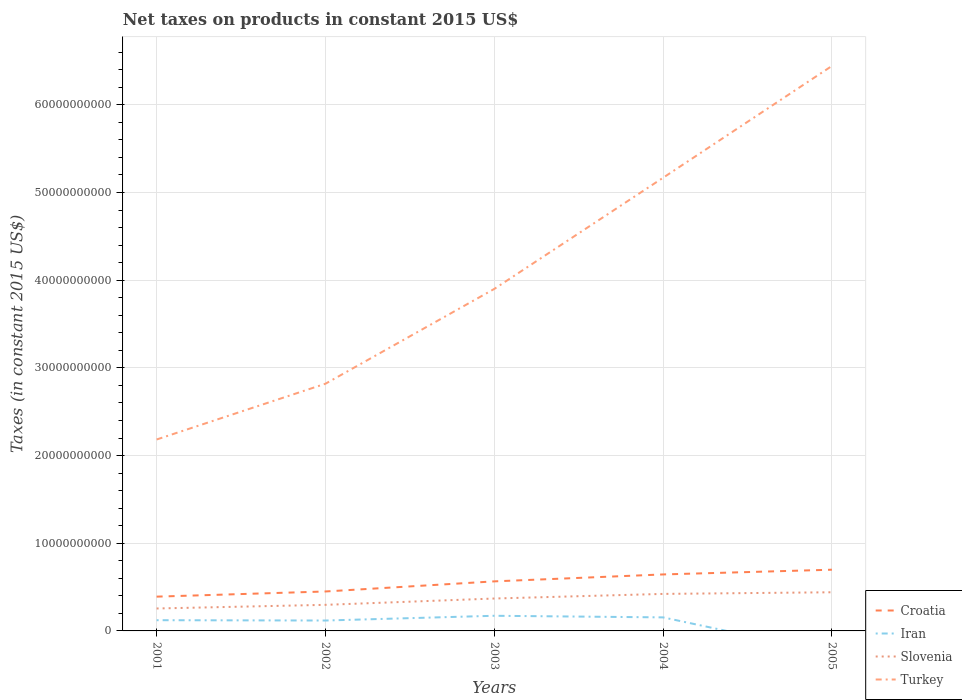Is the number of lines equal to the number of legend labels?
Ensure brevity in your answer.  No. Across all years, what is the maximum net taxes on products in Slovenia?
Give a very brief answer. 2.56e+09. What is the total net taxes on products in Croatia in the graph?
Keep it short and to the point. -5.90e+08. What is the difference between the highest and the second highest net taxes on products in Croatia?
Ensure brevity in your answer.  3.07e+09. Is the net taxes on products in Slovenia strictly greater than the net taxes on products in Turkey over the years?
Ensure brevity in your answer.  Yes. What is the difference between two consecutive major ticks on the Y-axis?
Ensure brevity in your answer.  1.00e+1. Are the values on the major ticks of Y-axis written in scientific E-notation?
Give a very brief answer. No. Does the graph contain any zero values?
Your response must be concise. Yes. Where does the legend appear in the graph?
Offer a very short reply. Bottom right. How many legend labels are there?
Provide a short and direct response. 4. What is the title of the graph?
Your answer should be very brief. Net taxes on products in constant 2015 US$. Does "North America" appear as one of the legend labels in the graph?
Offer a very short reply. No. What is the label or title of the X-axis?
Make the answer very short. Years. What is the label or title of the Y-axis?
Your response must be concise. Taxes (in constant 2015 US$). What is the Taxes (in constant 2015 US$) in Croatia in 2001?
Your answer should be very brief. 3.91e+09. What is the Taxes (in constant 2015 US$) of Iran in 2001?
Ensure brevity in your answer.  1.22e+09. What is the Taxes (in constant 2015 US$) in Slovenia in 2001?
Offer a very short reply. 2.56e+09. What is the Taxes (in constant 2015 US$) of Turkey in 2001?
Provide a succinct answer. 2.18e+1. What is the Taxes (in constant 2015 US$) in Croatia in 2002?
Make the answer very short. 4.50e+09. What is the Taxes (in constant 2015 US$) in Iran in 2002?
Give a very brief answer. 1.19e+09. What is the Taxes (in constant 2015 US$) of Slovenia in 2002?
Offer a very short reply. 2.98e+09. What is the Taxes (in constant 2015 US$) in Turkey in 2002?
Your answer should be compact. 2.82e+1. What is the Taxes (in constant 2015 US$) of Croatia in 2003?
Provide a succinct answer. 5.65e+09. What is the Taxes (in constant 2015 US$) in Iran in 2003?
Give a very brief answer. 1.73e+09. What is the Taxes (in constant 2015 US$) of Slovenia in 2003?
Your response must be concise. 3.70e+09. What is the Taxes (in constant 2015 US$) in Turkey in 2003?
Offer a terse response. 3.90e+1. What is the Taxes (in constant 2015 US$) of Croatia in 2004?
Your answer should be very brief. 6.44e+09. What is the Taxes (in constant 2015 US$) of Iran in 2004?
Ensure brevity in your answer.  1.54e+09. What is the Taxes (in constant 2015 US$) in Slovenia in 2004?
Your answer should be very brief. 4.22e+09. What is the Taxes (in constant 2015 US$) in Turkey in 2004?
Offer a very short reply. 5.17e+1. What is the Taxes (in constant 2015 US$) in Croatia in 2005?
Your answer should be very brief. 6.98e+09. What is the Taxes (in constant 2015 US$) in Slovenia in 2005?
Your answer should be compact. 4.41e+09. What is the Taxes (in constant 2015 US$) in Turkey in 2005?
Offer a very short reply. 6.44e+1. Across all years, what is the maximum Taxes (in constant 2015 US$) in Croatia?
Offer a terse response. 6.98e+09. Across all years, what is the maximum Taxes (in constant 2015 US$) in Iran?
Keep it short and to the point. 1.73e+09. Across all years, what is the maximum Taxes (in constant 2015 US$) in Slovenia?
Your response must be concise. 4.41e+09. Across all years, what is the maximum Taxes (in constant 2015 US$) of Turkey?
Provide a short and direct response. 6.44e+1. Across all years, what is the minimum Taxes (in constant 2015 US$) in Croatia?
Your response must be concise. 3.91e+09. Across all years, what is the minimum Taxes (in constant 2015 US$) in Slovenia?
Give a very brief answer. 2.56e+09. Across all years, what is the minimum Taxes (in constant 2015 US$) of Turkey?
Provide a succinct answer. 2.18e+1. What is the total Taxes (in constant 2015 US$) in Croatia in the graph?
Your answer should be compact. 2.75e+1. What is the total Taxes (in constant 2015 US$) in Iran in the graph?
Offer a terse response. 5.68e+09. What is the total Taxes (in constant 2015 US$) in Slovenia in the graph?
Make the answer very short. 1.79e+1. What is the total Taxes (in constant 2015 US$) of Turkey in the graph?
Offer a very short reply. 2.05e+11. What is the difference between the Taxes (in constant 2015 US$) of Croatia in 2001 and that in 2002?
Your answer should be very brief. -5.90e+08. What is the difference between the Taxes (in constant 2015 US$) of Iran in 2001 and that in 2002?
Ensure brevity in your answer.  3.65e+07. What is the difference between the Taxes (in constant 2015 US$) of Slovenia in 2001 and that in 2002?
Keep it short and to the point. -4.16e+08. What is the difference between the Taxes (in constant 2015 US$) of Turkey in 2001 and that in 2002?
Ensure brevity in your answer.  -6.36e+09. What is the difference between the Taxes (in constant 2015 US$) of Croatia in 2001 and that in 2003?
Provide a short and direct response. -1.74e+09. What is the difference between the Taxes (in constant 2015 US$) in Iran in 2001 and that in 2003?
Provide a short and direct response. -5.05e+08. What is the difference between the Taxes (in constant 2015 US$) of Slovenia in 2001 and that in 2003?
Your response must be concise. -1.14e+09. What is the difference between the Taxes (in constant 2015 US$) in Turkey in 2001 and that in 2003?
Your answer should be compact. -1.72e+1. What is the difference between the Taxes (in constant 2015 US$) of Croatia in 2001 and that in 2004?
Make the answer very short. -2.53e+09. What is the difference between the Taxes (in constant 2015 US$) of Iran in 2001 and that in 2004?
Ensure brevity in your answer.  -3.21e+08. What is the difference between the Taxes (in constant 2015 US$) in Slovenia in 2001 and that in 2004?
Keep it short and to the point. -1.66e+09. What is the difference between the Taxes (in constant 2015 US$) of Turkey in 2001 and that in 2004?
Your response must be concise. -2.98e+1. What is the difference between the Taxes (in constant 2015 US$) in Croatia in 2001 and that in 2005?
Make the answer very short. -3.07e+09. What is the difference between the Taxes (in constant 2015 US$) in Slovenia in 2001 and that in 2005?
Keep it short and to the point. -1.85e+09. What is the difference between the Taxes (in constant 2015 US$) in Turkey in 2001 and that in 2005?
Your answer should be compact. -4.26e+1. What is the difference between the Taxes (in constant 2015 US$) of Croatia in 2002 and that in 2003?
Give a very brief answer. -1.15e+09. What is the difference between the Taxes (in constant 2015 US$) of Iran in 2002 and that in 2003?
Provide a succinct answer. -5.42e+08. What is the difference between the Taxes (in constant 2015 US$) of Slovenia in 2002 and that in 2003?
Provide a succinct answer. -7.21e+08. What is the difference between the Taxes (in constant 2015 US$) of Turkey in 2002 and that in 2003?
Offer a very short reply. -1.08e+1. What is the difference between the Taxes (in constant 2015 US$) of Croatia in 2002 and that in 2004?
Make the answer very short. -1.94e+09. What is the difference between the Taxes (in constant 2015 US$) in Iran in 2002 and that in 2004?
Offer a terse response. -3.58e+08. What is the difference between the Taxes (in constant 2015 US$) in Slovenia in 2002 and that in 2004?
Provide a short and direct response. -1.25e+09. What is the difference between the Taxes (in constant 2015 US$) in Turkey in 2002 and that in 2004?
Provide a short and direct response. -2.35e+1. What is the difference between the Taxes (in constant 2015 US$) of Croatia in 2002 and that in 2005?
Provide a short and direct response. -2.48e+09. What is the difference between the Taxes (in constant 2015 US$) in Slovenia in 2002 and that in 2005?
Offer a very short reply. -1.43e+09. What is the difference between the Taxes (in constant 2015 US$) of Turkey in 2002 and that in 2005?
Offer a very short reply. -3.62e+1. What is the difference between the Taxes (in constant 2015 US$) of Croatia in 2003 and that in 2004?
Keep it short and to the point. -7.91e+08. What is the difference between the Taxes (in constant 2015 US$) in Iran in 2003 and that in 2004?
Offer a terse response. 1.84e+08. What is the difference between the Taxes (in constant 2015 US$) in Slovenia in 2003 and that in 2004?
Your response must be concise. -5.26e+08. What is the difference between the Taxes (in constant 2015 US$) in Turkey in 2003 and that in 2004?
Ensure brevity in your answer.  -1.27e+1. What is the difference between the Taxes (in constant 2015 US$) of Croatia in 2003 and that in 2005?
Keep it short and to the point. -1.33e+09. What is the difference between the Taxes (in constant 2015 US$) in Slovenia in 2003 and that in 2005?
Ensure brevity in your answer.  -7.13e+08. What is the difference between the Taxes (in constant 2015 US$) in Turkey in 2003 and that in 2005?
Your answer should be compact. -2.54e+1. What is the difference between the Taxes (in constant 2015 US$) of Croatia in 2004 and that in 2005?
Make the answer very short. -5.39e+08. What is the difference between the Taxes (in constant 2015 US$) in Slovenia in 2004 and that in 2005?
Keep it short and to the point. -1.87e+08. What is the difference between the Taxes (in constant 2015 US$) of Turkey in 2004 and that in 2005?
Offer a terse response. -1.28e+1. What is the difference between the Taxes (in constant 2015 US$) of Croatia in 2001 and the Taxes (in constant 2015 US$) of Iran in 2002?
Your answer should be very brief. 2.72e+09. What is the difference between the Taxes (in constant 2015 US$) in Croatia in 2001 and the Taxes (in constant 2015 US$) in Slovenia in 2002?
Offer a very short reply. 9.34e+08. What is the difference between the Taxes (in constant 2015 US$) of Croatia in 2001 and the Taxes (in constant 2015 US$) of Turkey in 2002?
Offer a very short reply. -2.43e+1. What is the difference between the Taxes (in constant 2015 US$) of Iran in 2001 and the Taxes (in constant 2015 US$) of Slovenia in 2002?
Offer a very short reply. -1.75e+09. What is the difference between the Taxes (in constant 2015 US$) of Iran in 2001 and the Taxes (in constant 2015 US$) of Turkey in 2002?
Offer a very short reply. -2.70e+1. What is the difference between the Taxes (in constant 2015 US$) of Slovenia in 2001 and the Taxes (in constant 2015 US$) of Turkey in 2002?
Your answer should be very brief. -2.56e+1. What is the difference between the Taxes (in constant 2015 US$) in Croatia in 2001 and the Taxes (in constant 2015 US$) in Iran in 2003?
Offer a terse response. 2.18e+09. What is the difference between the Taxes (in constant 2015 US$) of Croatia in 2001 and the Taxes (in constant 2015 US$) of Slovenia in 2003?
Make the answer very short. 2.13e+08. What is the difference between the Taxes (in constant 2015 US$) in Croatia in 2001 and the Taxes (in constant 2015 US$) in Turkey in 2003?
Your answer should be compact. -3.51e+1. What is the difference between the Taxes (in constant 2015 US$) in Iran in 2001 and the Taxes (in constant 2015 US$) in Slovenia in 2003?
Your response must be concise. -2.47e+09. What is the difference between the Taxes (in constant 2015 US$) in Iran in 2001 and the Taxes (in constant 2015 US$) in Turkey in 2003?
Ensure brevity in your answer.  -3.78e+1. What is the difference between the Taxes (in constant 2015 US$) in Slovenia in 2001 and the Taxes (in constant 2015 US$) in Turkey in 2003?
Ensure brevity in your answer.  -3.64e+1. What is the difference between the Taxes (in constant 2015 US$) in Croatia in 2001 and the Taxes (in constant 2015 US$) in Iran in 2004?
Your answer should be very brief. 2.37e+09. What is the difference between the Taxes (in constant 2015 US$) in Croatia in 2001 and the Taxes (in constant 2015 US$) in Slovenia in 2004?
Provide a succinct answer. -3.12e+08. What is the difference between the Taxes (in constant 2015 US$) of Croatia in 2001 and the Taxes (in constant 2015 US$) of Turkey in 2004?
Provide a short and direct response. -4.78e+1. What is the difference between the Taxes (in constant 2015 US$) of Iran in 2001 and the Taxes (in constant 2015 US$) of Slovenia in 2004?
Offer a very short reply. -3.00e+09. What is the difference between the Taxes (in constant 2015 US$) of Iran in 2001 and the Taxes (in constant 2015 US$) of Turkey in 2004?
Make the answer very short. -5.05e+1. What is the difference between the Taxes (in constant 2015 US$) in Slovenia in 2001 and the Taxes (in constant 2015 US$) in Turkey in 2004?
Offer a terse response. -4.91e+1. What is the difference between the Taxes (in constant 2015 US$) in Croatia in 2001 and the Taxes (in constant 2015 US$) in Slovenia in 2005?
Keep it short and to the point. -4.99e+08. What is the difference between the Taxes (in constant 2015 US$) of Croatia in 2001 and the Taxes (in constant 2015 US$) of Turkey in 2005?
Provide a short and direct response. -6.05e+1. What is the difference between the Taxes (in constant 2015 US$) in Iran in 2001 and the Taxes (in constant 2015 US$) in Slovenia in 2005?
Offer a terse response. -3.19e+09. What is the difference between the Taxes (in constant 2015 US$) in Iran in 2001 and the Taxes (in constant 2015 US$) in Turkey in 2005?
Your answer should be very brief. -6.32e+1. What is the difference between the Taxes (in constant 2015 US$) in Slovenia in 2001 and the Taxes (in constant 2015 US$) in Turkey in 2005?
Offer a very short reply. -6.19e+1. What is the difference between the Taxes (in constant 2015 US$) of Croatia in 2002 and the Taxes (in constant 2015 US$) of Iran in 2003?
Your answer should be very brief. 2.77e+09. What is the difference between the Taxes (in constant 2015 US$) of Croatia in 2002 and the Taxes (in constant 2015 US$) of Slovenia in 2003?
Make the answer very short. 8.03e+08. What is the difference between the Taxes (in constant 2015 US$) in Croatia in 2002 and the Taxes (in constant 2015 US$) in Turkey in 2003?
Give a very brief answer. -3.45e+1. What is the difference between the Taxes (in constant 2015 US$) in Iran in 2002 and the Taxes (in constant 2015 US$) in Slovenia in 2003?
Keep it short and to the point. -2.51e+09. What is the difference between the Taxes (in constant 2015 US$) in Iran in 2002 and the Taxes (in constant 2015 US$) in Turkey in 2003?
Ensure brevity in your answer.  -3.78e+1. What is the difference between the Taxes (in constant 2015 US$) of Slovenia in 2002 and the Taxes (in constant 2015 US$) of Turkey in 2003?
Ensure brevity in your answer.  -3.60e+1. What is the difference between the Taxes (in constant 2015 US$) in Croatia in 2002 and the Taxes (in constant 2015 US$) in Iran in 2004?
Your answer should be compact. 2.95e+09. What is the difference between the Taxes (in constant 2015 US$) of Croatia in 2002 and the Taxes (in constant 2015 US$) of Slovenia in 2004?
Offer a very short reply. 2.77e+08. What is the difference between the Taxes (in constant 2015 US$) of Croatia in 2002 and the Taxes (in constant 2015 US$) of Turkey in 2004?
Offer a terse response. -4.72e+1. What is the difference between the Taxes (in constant 2015 US$) in Iran in 2002 and the Taxes (in constant 2015 US$) in Slovenia in 2004?
Keep it short and to the point. -3.04e+09. What is the difference between the Taxes (in constant 2015 US$) in Iran in 2002 and the Taxes (in constant 2015 US$) in Turkey in 2004?
Your answer should be very brief. -5.05e+1. What is the difference between the Taxes (in constant 2015 US$) in Slovenia in 2002 and the Taxes (in constant 2015 US$) in Turkey in 2004?
Your answer should be compact. -4.87e+1. What is the difference between the Taxes (in constant 2015 US$) of Croatia in 2002 and the Taxes (in constant 2015 US$) of Slovenia in 2005?
Your response must be concise. 9.03e+07. What is the difference between the Taxes (in constant 2015 US$) of Croatia in 2002 and the Taxes (in constant 2015 US$) of Turkey in 2005?
Give a very brief answer. -5.99e+1. What is the difference between the Taxes (in constant 2015 US$) of Iran in 2002 and the Taxes (in constant 2015 US$) of Slovenia in 2005?
Provide a short and direct response. -3.22e+09. What is the difference between the Taxes (in constant 2015 US$) in Iran in 2002 and the Taxes (in constant 2015 US$) in Turkey in 2005?
Offer a very short reply. -6.32e+1. What is the difference between the Taxes (in constant 2015 US$) of Slovenia in 2002 and the Taxes (in constant 2015 US$) of Turkey in 2005?
Ensure brevity in your answer.  -6.15e+1. What is the difference between the Taxes (in constant 2015 US$) in Croatia in 2003 and the Taxes (in constant 2015 US$) in Iran in 2004?
Keep it short and to the point. 4.11e+09. What is the difference between the Taxes (in constant 2015 US$) in Croatia in 2003 and the Taxes (in constant 2015 US$) in Slovenia in 2004?
Keep it short and to the point. 1.43e+09. What is the difference between the Taxes (in constant 2015 US$) of Croatia in 2003 and the Taxes (in constant 2015 US$) of Turkey in 2004?
Your answer should be very brief. -4.60e+1. What is the difference between the Taxes (in constant 2015 US$) in Iran in 2003 and the Taxes (in constant 2015 US$) in Slovenia in 2004?
Your response must be concise. -2.49e+09. What is the difference between the Taxes (in constant 2015 US$) of Iran in 2003 and the Taxes (in constant 2015 US$) of Turkey in 2004?
Provide a short and direct response. -5.00e+1. What is the difference between the Taxes (in constant 2015 US$) in Slovenia in 2003 and the Taxes (in constant 2015 US$) in Turkey in 2004?
Keep it short and to the point. -4.80e+1. What is the difference between the Taxes (in constant 2015 US$) of Croatia in 2003 and the Taxes (in constant 2015 US$) of Slovenia in 2005?
Offer a terse response. 1.24e+09. What is the difference between the Taxes (in constant 2015 US$) of Croatia in 2003 and the Taxes (in constant 2015 US$) of Turkey in 2005?
Give a very brief answer. -5.88e+1. What is the difference between the Taxes (in constant 2015 US$) of Iran in 2003 and the Taxes (in constant 2015 US$) of Slovenia in 2005?
Ensure brevity in your answer.  -2.68e+09. What is the difference between the Taxes (in constant 2015 US$) in Iran in 2003 and the Taxes (in constant 2015 US$) in Turkey in 2005?
Ensure brevity in your answer.  -6.27e+1. What is the difference between the Taxes (in constant 2015 US$) in Slovenia in 2003 and the Taxes (in constant 2015 US$) in Turkey in 2005?
Ensure brevity in your answer.  -6.07e+1. What is the difference between the Taxes (in constant 2015 US$) in Croatia in 2004 and the Taxes (in constant 2015 US$) in Slovenia in 2005?
Make the answer very short. 2.03e+09. What is the difference between the Taxes (in constant 2015 US$) in Croatia in 2004 and the Taxes (in constant 2015 US$) in Turkey in 2005?
Provide a succinct answer. -5.80e+1. What is the difference between the Taxes (in constant 2015 US$) in Iran in 2004 and the Taxes (in constant 2015 US$) in Slovenia in 2005?
Ensure brevity in your answer.  -2.86e+09. What is the difference between the Taxes (in constant 2015 US$) of Iran in 2004 and the Taxes (in constant 2015 US$) of Turkey in 2005?
Your response must be concise. -6.29e+1. What is the difference between the Taxes (in constant 2015 US$) in Slovenia in 2004 and the Taxes (in constant 2015 US$) in Turkey in 2005?
Keep it short and to the point. -6.02e+1. What is the average Taxes (in constant 2015 US$) of Croatia per year?
Keep it short and to the point. 5.50e+09. What is the average Taxes (in constant 2015 US$) in Iran per year?
Provide a succinct answer. 1.14e+09. What is the average Taxes (in constant 2015 US$) in Slovenia per year?
Your response must be concise. 3.57e+09. What is the average Taxes (in constant 2015 US$) in Turkey per year?
Ensure brevity in your answer.  4.10e+1. In the year 2001, what is the difference between the Taxes (in constant 2015 US$) in Croatia and Taxes (in constant 2015 US$) in Iran?
Offer a very short reply. 2.69e+09. In the year 2001, what is the difference between the Taxes (in constant 2015 US$) of Croatia and Taxes (in constant 2015 US$) of Slovenia?
Your answer should be compact. 1.35e+09. In the year 2001, what is the difference between the Taxes (in constant 2015 US$) in Croatia and Taxes (in constant 2015 US$) in Turkey?
Offer a very short reply. -1.79e+1. In the year 2001, what is the difference between the Taxes (in constant 2015 US$) of Iran and Taxes (in constant 2015 US$) of Slovenia?
Provide a short and direct response. -1.34e+09. In the year 2001, what is the difference between the Taxes (in constant 2015 US$) of Iran and Taxes (in constant 2015 US$) of Turkey?
Keep it short and to the point. -2.06e+1. In the year 2001, what is the difference between the Taxes (in constant 2015 US$) in Slovenia and Taxes (in constant 2015 US$) in Turkey?
Your answer should be compact. -1.93e+1. In the year 2002, what is the difference between the Taxes (in constant 2015 US$) of Croatia and Taxes (in constant 2015 US$) of Iran?
Give a very brief answer. 3.31e+09. In the year 2002, what is the difference between the Taxes (in constant 2015 US$) in Croatia and Taxes (in constant 2015 US$) in Slovenia?
Your answer should be very brief. 1.52e+09. In the year 2002, what is the difference between the Taxes (in constant 2015 US$) of Croatia and Taxes (in constant 2015 US$) of Turkey?
Make the answer very short. -2.37e+1. In the year 2002, what is the difference between the Taxes (in constant 2015 US$) of Iran and Taxes (in constant 2015 US$) of Slovenia?
Offer a very short reply. -1.79e+09. In the year 2002, what is the difference between the Taxes (in constant 2015 US$) of Iran and Taxes (in constant 2015 US$) of Turkey?
Your answer should be very brief. -2.70e+1. In the year 2002, what is the difference between the Taxes (in constant 2015 US$) of Slovenia and Taxes (in constant 2015 US$) of Turkey?
Provide a short and direct response. -2.52e+1. In the year 2003, what is the difference between the Taxes (in constant 2015 US$) of Croatia and Taxes (in constant 2015 US$) of Iran?
Provide a short and direct response. 3.92e+09. In the year 2003, what is the difference between the Taxes (in constant 2015 US$) of Croatia and Taxes (in constant 2015 US$) of Slovenia?
Give a very brief answer. 1.96e+09. In the year 2003, what is the difference between the Taxes (in constant 2015 US$) of Croatia and Taxes (in constant 2015 US$) of Turkey?
Provide a succinct answer. -3.34e+1. In the year 2003, what is the difference between the Taxes (in constant 2015 US$) of Iran and Taxes (in constant 2015 US$) of Slovenia?
Provide a short and direct response. -1.97e+09. In the year 2003, what is the difference between the Taxes (in constant 2015 US$) of Iran and Taxes (in constant 2015 US$) of Turkey?
Give a very brief answer. -3.73e+1. In the year 2003, what is the difference between the Taxes (in constant 2015 US$) in Slovenia and Taxes (in constant 2015 US$) in Turkey?
Provide a short and direct response. -3.53e+1. In the year 2004, what is the difference between the Taxes (in constant 2015 US$) of Croatia and Taxes (in constant 2015 US$) of Iran?
Offer a very short reply. 4.90e+09. In the year 2004, what is the difference between the Taxes (in constant 2015 US$) in Croatia and Taxes (in constant 2015 US$) in Slovenia?
Your answer should be compact. 2.22e+09. In the year 2004, what is the difference between the Taxes (in constant 2015 US$) in Croatia and Taxes (in constant 2015 US$) in Turkey?
Provide a short and direct response. -4.52e+1. In the year 2004, what is the difference between the Taxes (in constant 2015 US$) in Iran and Taxes (in constant 2015 US$) in Slovenia?
Make the answer very short. -2.68e+09. In the year 2004, what is the difference between the Taxes (in constant 2015 US$) of Iran and Taxes (in constant 2015 US$) of Turkey?
Give a very brief answer. -5.01e+1. In the year 2004, what is the difference between the Taxes (in constant 2015 US$) of Slovenia and Taxes (in constant 2015 US$) of Turkey?
Offer a very short reply. -4.75e+1. In the year 2005, what is the difference between the Taxes (in constant 2015 US$) of Croatia and Taxes (in constant 2015 US$) of Slovenia?
Make the answer very short. 2.57e+09. In the year 2005, what is the difference between the Taxes (in constant 2015 US$) in Croatia and Taxes (in constant 2015 US$) in Turkey?
Make the answer very short. -5.75e+1. In the year 2005, what is the difference between the Taxes (in constant 2015 US$) in Slovenia and Taxes (in constant 2015 US$) in Turkey?
Provide a succinct answer. -6.00e+1. What is the ratio of the Taxes (in constant 2015 US$) of Croatia in 2001 to that in 2002?
Offer a very short reply. 0.87. What is the ratio of the Taxes (in constant 2015 US$) of Iran in 2001 to that in 2002?
Provide a succinct answer. 1.03. What is the ratio of the Taxes (in constant 2015 US$) of Slovenia in 2001 to that in 2002?
Keep it short and to the point. 0.86. What is the ratio of the Taxes (in constant 2015 US$) in Turkey in 2001 to that in 2002?
Give a very brief answer. 0.77. What is the ratio of the Taxes (in constant 2015 US$) in Croatia in 2001 to that in 2003?
Your response must be concise. 0.69. What is the ratio of the Taxes (in constant 2015 US$) of Iran in 2001 to that in 2003?
Provide a short and direct response. 0.71. What is the ratio of the Taxes (in constant 2015 US$) of Slovenia in 2001 to that in 2003?
Provide a short and direct response. 0.69. What is the ratio of the Taxes (in constant 2015 US$) of Turkey in 2001 to that in 2003?
Your answer should be very brief. 0.56. What is the ratio of the Taxes (in constant 2015 US$) in Croatia in 2001 to that in 2004?
Your response must be concise. 0.61. What is the ratio of the Taxes (in constant 2015 US$) of Iran in 2001 to that in 2004?
Give a very brief answer. 0.79. What is the ratio of the Taxes (in constant 2015 US$) of Slovenia in 2001 to that in 2004?
Offer a terse response. 0.61. What is the ratio of the Taxes (in constant 2015 US$) in Turkey in 2001 to that in 2004?
Keep it short and to the point. 0.42. What is the ratio of the Taxes (in constant 2015 US$) in Croatia in 2001 to that in 2005?
Offer a very short reply. 0.56. What is the ratio of the Taxes (in constant 2015 US$) of Slovenia in 2001 to that in 2005?
Provide a succinct answer. 0.58. What is the ratio of the Taxes (in constant 2015 US$) of Turkey in 2001 to that in 2005?
Provide a short and direct response. 0.34. What is the ratio of the Taxes (in constant 2015 US$) in Croatia in 2002 to that in 2003?
Offer a very short reply. 0.8. What is the ratio of the Taxes (in constant 2015 US$) in Iran in 2002 to that in 2003?
Offer a terse response. 0.69. What is the ratio of the Taxes (in constant 2015 US$) of Slovenia in 2002 to that in 2003?
Your answer should be compact. 0.81. What is the ratio of the Taxes (in constant 2015 US$) in Turkey in 2002 to that in 2003?
Provide a succinct answer. 0.72. What is the ratio of the Taxes (in constant 2015 US$) of Croatia in 2002 to that in 2004?
Offer a very short reply. 0.7. What is the ratio of the Taxes (in constant 2015 US$) of Iran in 2002 to that in 2004?
Provide a succinct answer. 0.77. What is the ratio of the Taxes (in constant 2015 US$) in Slovenia in 2002 to that in 2004?
Your answer should be compact. 0.7. What is the ratio of the Taxes (in constant 2015 US$) of Turkey in 2002 to that in 2004?
Your answer should be very brief. 0.55. What is the ratio of the Taxes (in constant 2015 US$) of Croatia in 2002 to that in 2005?
Provide a short and direct response. 0.64. What is the ratio of the Taxes (in constant 2015 US$) of Slovenia in 2002 to that in 2005?
Make the answer very short. 0.67. What is the ratio of the Taxes (in constant 2015 US$) in Turkey in 2002 to that in 2005?
Offer a very short reply. 0.44. What is the ratio of the Taxes (in constant 2015 US$) in Croatia in 2003 to that in 2004?
Your response must be concise. 0.88. What is the ratio of the Taxes (in constant 2015 US$) in Iran in 2003 to that in 2004?
Provide a succinct answer. 1.12. What is the ratio of the Taxes (in constant 2015 US$) of Slovenia in 2003 to that in 2004?
Provide a short and direct response. 0.88. What is the ratio of the Taxes (in constant 2015 US$) in Turkey in 2003 to that in 2004?
Make the answer very short. 0.75. What is the ratio of the Taxes (in constant 2015 US$) in Croatia in 2003 to that in 2005?
Keep it short and to the point. 0.81. What is the ratio of the Taxes (in constant 2015 US$) in Slovenia in 2003 to that in 2005?
Give a very brief answer. 0.84. What is the ratio of the Taxes (in constant 2015 US$) in Turkey in 2003 to that in 2005?
Provide a succinct answer. 0.61. What is the ratio of the Taxes (in constant 2015 US$) of Croatia in 2004 to that in 2005?
Offer a terse response. 0.92. What is the ratio of the Taxes (in constant 2015 US$) in Slovenia in 2004 to that in 2005?
Your response must be concise. 0.96. What is the ratio of the Taxes (in constant 2015 US$) in Turkey in 2004 to that in 2005?
Your answer should be compact. 0.8. What is the difference between the highest and the second highest Taxes (in constant 2015 US$) in Croatia?
Provide a succinct answer. 5.39e+08. What is the difference between the highest and the second highest Taxes (in constant 2015 US$) in Iran?
Keep it short and to the point. 1.84e+08. What is the difference between the highest and the second highest Taxes (in constant 2015 US$) in Slovenia?
Make the answer very short. 1.87e+08. What is the difference between the highest and the second highest Taxes (in constant 2015 US$) of Turkey?
Your response must be concise. 1.28e+1. What is the difference between the highest and the lowest Taxes (in constant 2015 US$) of Croatia?
Offer a very short reply. 3.07e+09. What is the difference between the highest and the lowest Taxes (in constant 2015 US$) in Iran?
Ensure brevity in your answer.  1.73e+09. What is the difference between the highest and the lowest Taxes (in constant 2015 US$) in Slovenia?
Provide a succinct answer. 1.85e+09. What is the difference between the highest and the lowest Taxes (in constant 2015 US$) in Turkey?
Provide a short and direct response. 4.26e+1. 